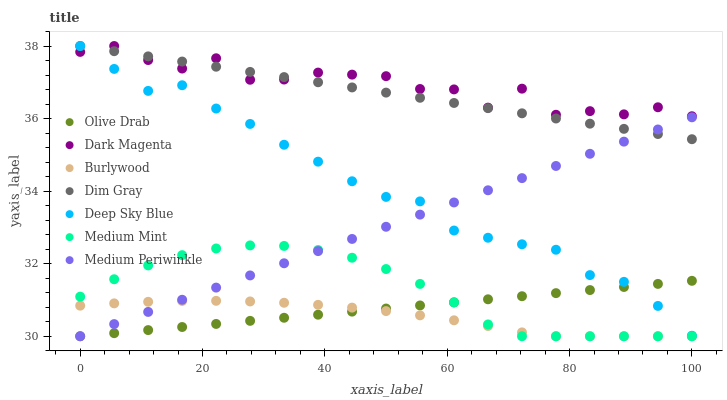Does Burlywood have the minimum area under the curve?
Answer yes or no. Yes. Does Dark Magenta have the maximum area under the curve?
Answer yes or no. Yes. Does Dim Gray have the minimum area under the curve?
Answer yes or no. No. Does Dim Gray have the maximum area under the curve?
Answer yes or no. No. Is Dim Gray the smoothest?
Answer yes or no. Yes. Is Dark Magenta the roughest?
Answer yes or no. Yes. Is Dark Magenta the smoothest?
Answer yes or no. No. Is Dim Gray the roughest?
Answer yes or no. No. Does Medium Mint have the lowest value?
Answer yes or no. Yes. Does Dim Gray have the lowest value?
Answer yes or no. No. Does Deep Sky Blue have the highest value?
Answer yes or no. Yes. Does Burlywood have the highest value?
Answer yes or no. No. Is Burlywood less than Dark Magenta?
Answer yes or no. Yes. Is Dark Magenta greater than Medium Mint?
Answer yes or no. Yes. Does Dim Gray intersect Dark Magenta?
Answer yes or no. Yes. Is Dim Gray less than Dark Magenta?
Answer yes or no. No. Is Dim Gray greater than Dark Magenta?
Answer yes or no. No. Does Burlywood intersect Dark Magenta?
Answer yes or no. No. 